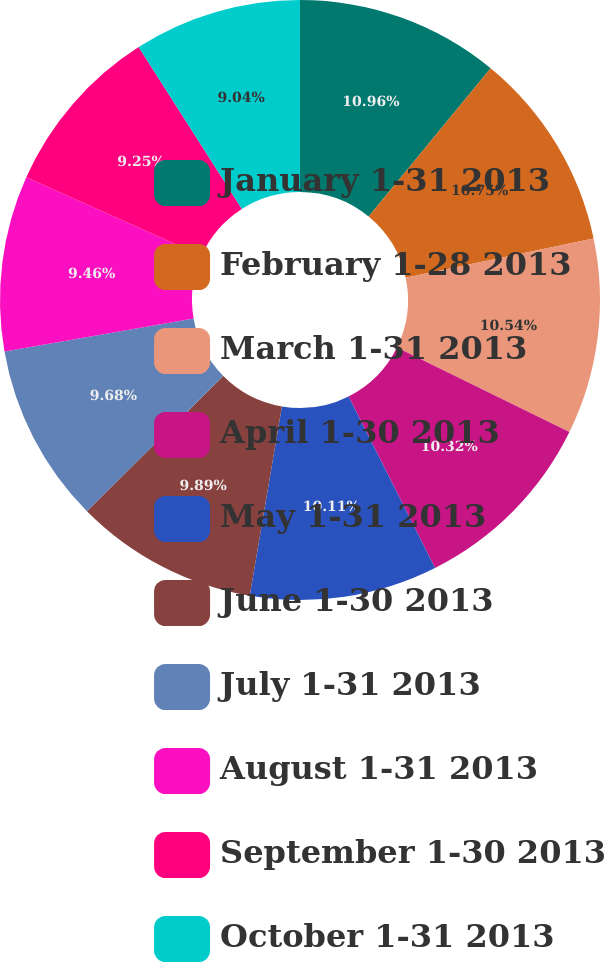<chart> <loc_0><loc_0><loc_500><loc_500><pie_chart><fcel>January 1-31 2013<fcel>February 1-28 2013<fcel>March 1-31 2013<fcel>April 1-30 2013<fcel>May 1-31 2013<fcel>June 1-30 2013<fcel>July 1-31 2013<fcel>August 1-31 2013<fcel>September 1-30 2013<fcel>October 1-31 2013<nl><fcel>10.96%<fcel>10.75%<fcel>10.54%<fcel>10.32%<fcel>10.11%<fcel>9.89%<fcel>9.68%<fcel>9.46%<fcel>9.25%<fcel>9.04%<nl></chart> 